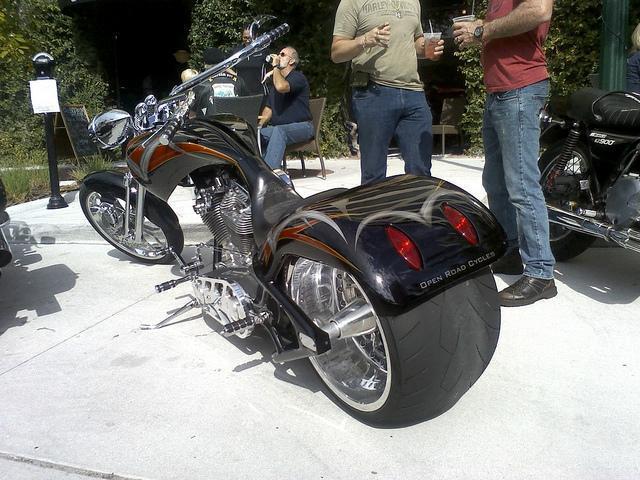How many people are in the photo?
Give a very brief answer. 3. How many motorcycles are in the photo?
Give a very brief answer. 2. How many bikes will fit on rack?
Give a very brief answer. 0. 